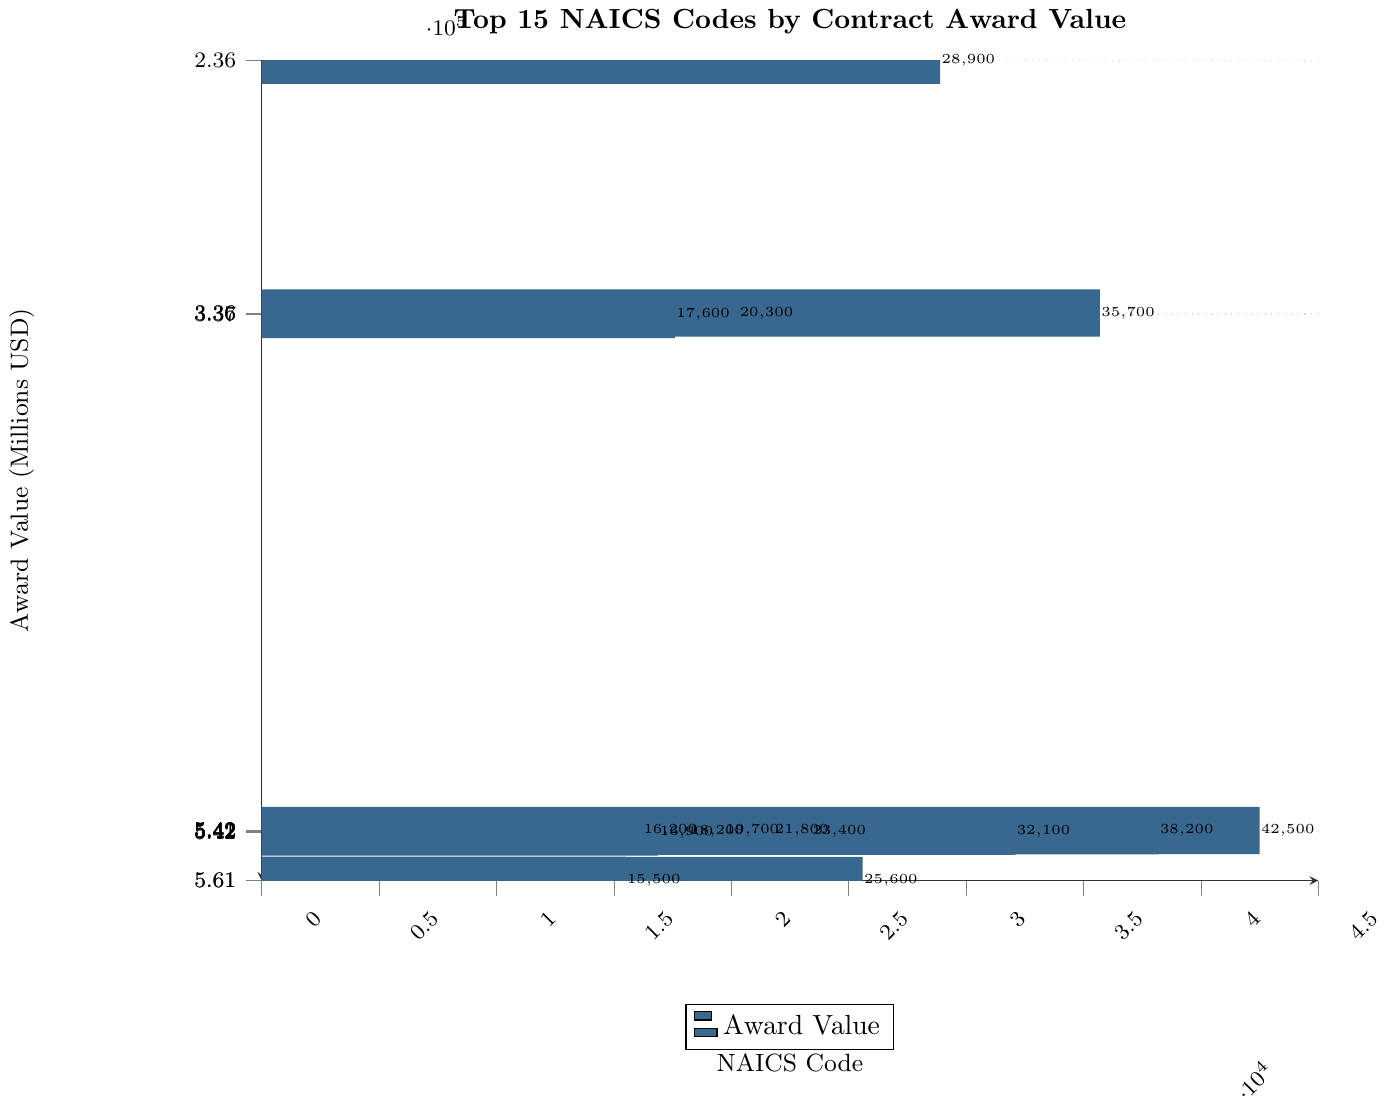What is the NAICS code with the highest award value in the current fiscal year? Looking at the bar chart, the NAICS code with the longest bar (highest award value) is 541330.
Answer: 541330 What is the difference in award value between the highest and lowest NAICS codes in the chart? The highest award value is for NAICS code 541330 at 42500 million USD, and the lowest is for NAICS code 561110 at 15500 million USD. The difference is 42500 - 15500 = 27000 million USD.
Answer: 27000 million USD Which NAICS code has a higher award value: 336411 or 541711? Comparing the lengths of the bars for NAICS codes 336411 and 541711, 336411 has a higher award value at 35700 million USD compared to 32100 million USD for 541711.
Answer: 336411 What is the average award value of the top 3 NAICS codes? The top 3 NAICS codes are 541330 (42500 million USD), 541519 (38200 million USD), and 336411 (35700 million USD). The average is (42500 + 38200 + 35700) / 3 = 38800 million USD.
Answer: 38800 million USD By how much does the award value of NAICS code 236220 exceed that of NAICS code 561210? The award value for NAICS code 236220 is 28900 million USD, and for 561210, it is 25600 million USD. The difference is 28900 - 25600 = 3300 million USD.
Answer: 3300 million USD How many NAICS codes have an award value greater than 20000 million USD? By counting the bars that extend past the 20000 million USD mark, we find that there are 8 NAICS codes with award values greater than 20000 million USD.
Answer: 8 Which two NAICS codes have the smallest difference in their award values? Comparing the differences between the consecutive bars, the smallest difference is between 541512 (21800 million USD) and 336413 (20300 million USD), which is 21800 - 20300 = 1500 million USD.
Answer: 541512 and 336413 What is the sum of the award values for NAICS codes 541330, 541519, and 336411? Adding the award values for 541330 (42500 million USD), 541519 (38200 million USD), and 336411 (35700 million USD), we get 42500 + 38200 + 35700 = 116400 million USD.
Answer: 116400 million USD Which NAICS code related to computer services has the highest award value? Among the computer-related services (541519, 541512, 541511, 541513), the highest award value is for 541519 at 38200 million USD.
Answer: 541519 What is the median award value of the given NAICS codes? The sorted values are: 15500, 16200, 16900, 17600, 18200, 19700, 20300, 21800, 23400, 25600, 28900, 32100, 35700, 38200, 42500. The median is the 8th value which is 21800 million USD.
Answer: 21800 million USD 